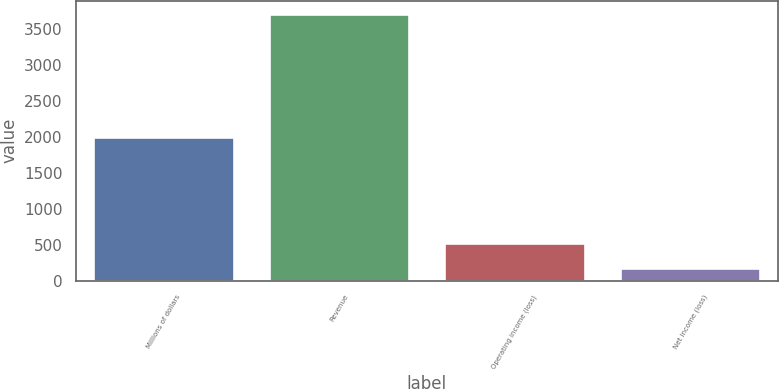<chart> <loc_0><loc_0><loc_500><loc_500><bar_chart><fcel>Millions of dollars<fcel>Revenue<fcel>Operating income (loss)<fcel>Net income (loss)<nl><fcel>2003<fcel>3708<fcel>528.3<fcel>175<nl></chart> 